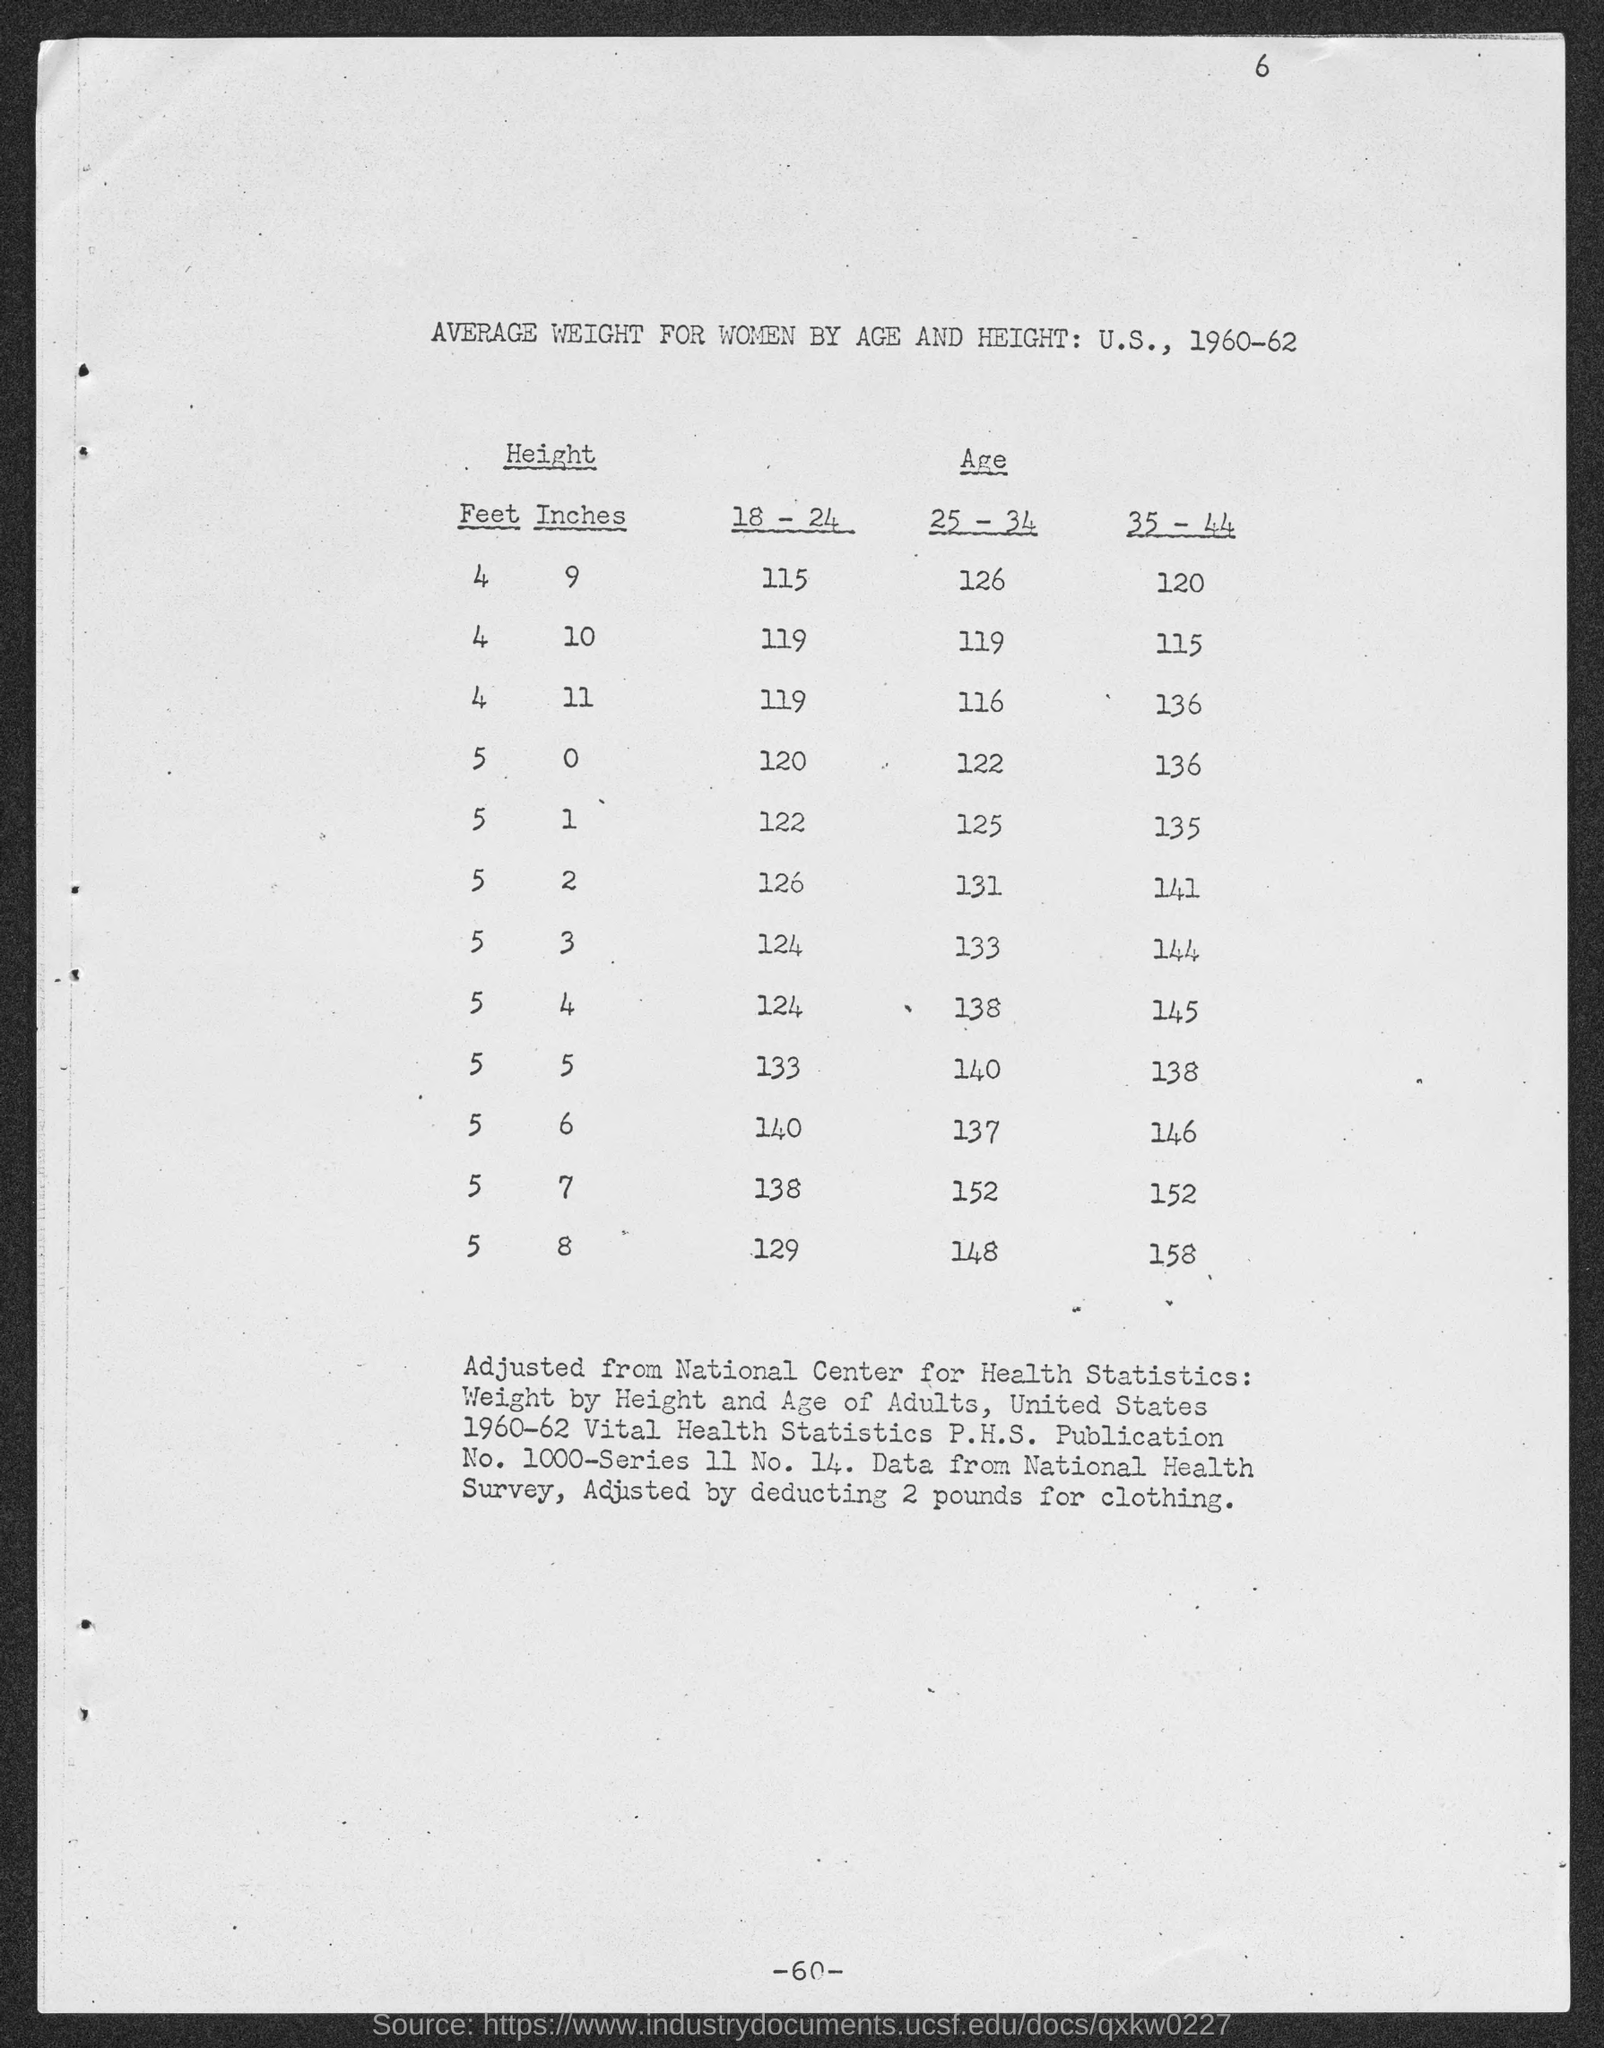Mention a couple of crucial points in this snapshot. The average weight of individuals in the age group of 18-24 years old and with a height of 4 feet 9 inches is approximately 115 pounds. The table title is "Average Weight for Women by Age and Height: U.S., 1960-62. 